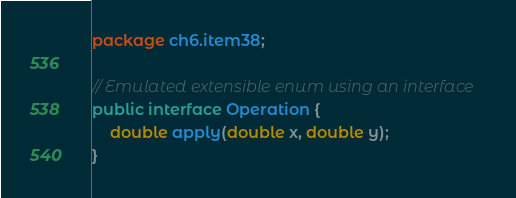Convert code to text. <code><loc_0><loc_0><loc_500><loc_500><_Java_>package ch6.item38;

// Emulated extensible enum using an interface
public interface Operation {
    double apply(double x, double y);
}</code> 